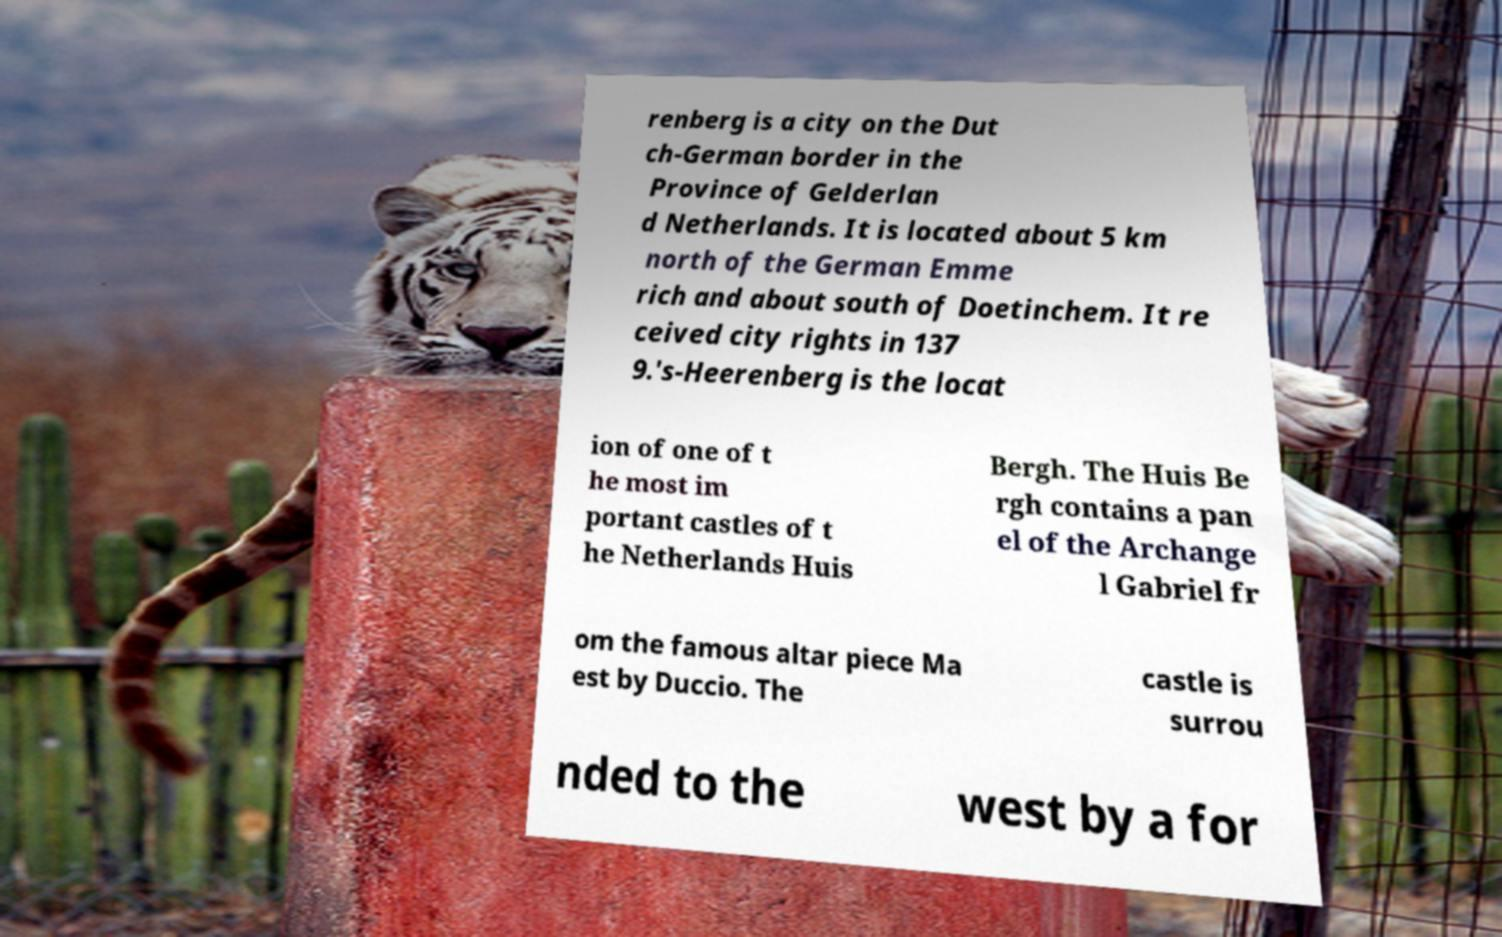Could you extract and type out the text from this image? renberg is a city on the Dut ch-German border in the Province of Gelderlan d Netherlands. It is located about 5 km north of the German Emme rich and about south of Doetinchem. It re ceived city rights in 137 9.'s-Heerenberg is the locat ion of one of t he most im portant castles of t he Netherlands Huis Bergh. The Huis Be rgh contains a pan el of the Archange l Gabriel fr om the famous altar piece Ma est by Duccio. The castle is surrou nded to the west by a for 